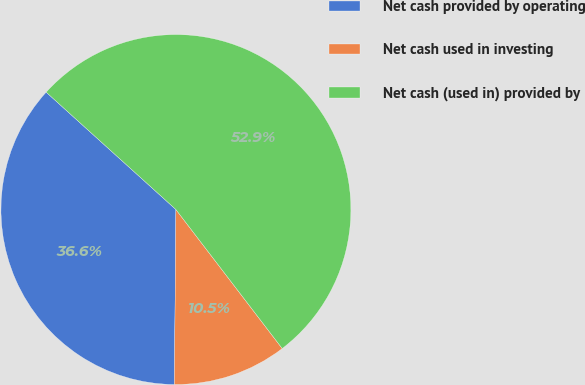<chart> <loc_0><loc_0><loc_500><loc_500><pie_chart><fcel>Net cash provided by operating<fcel>Net cash used in investing<fcel>Net cash (used in) provided by<nl><fcel>36.56%<fcel>10.53%<fcel>52.9%<nl></chart> 